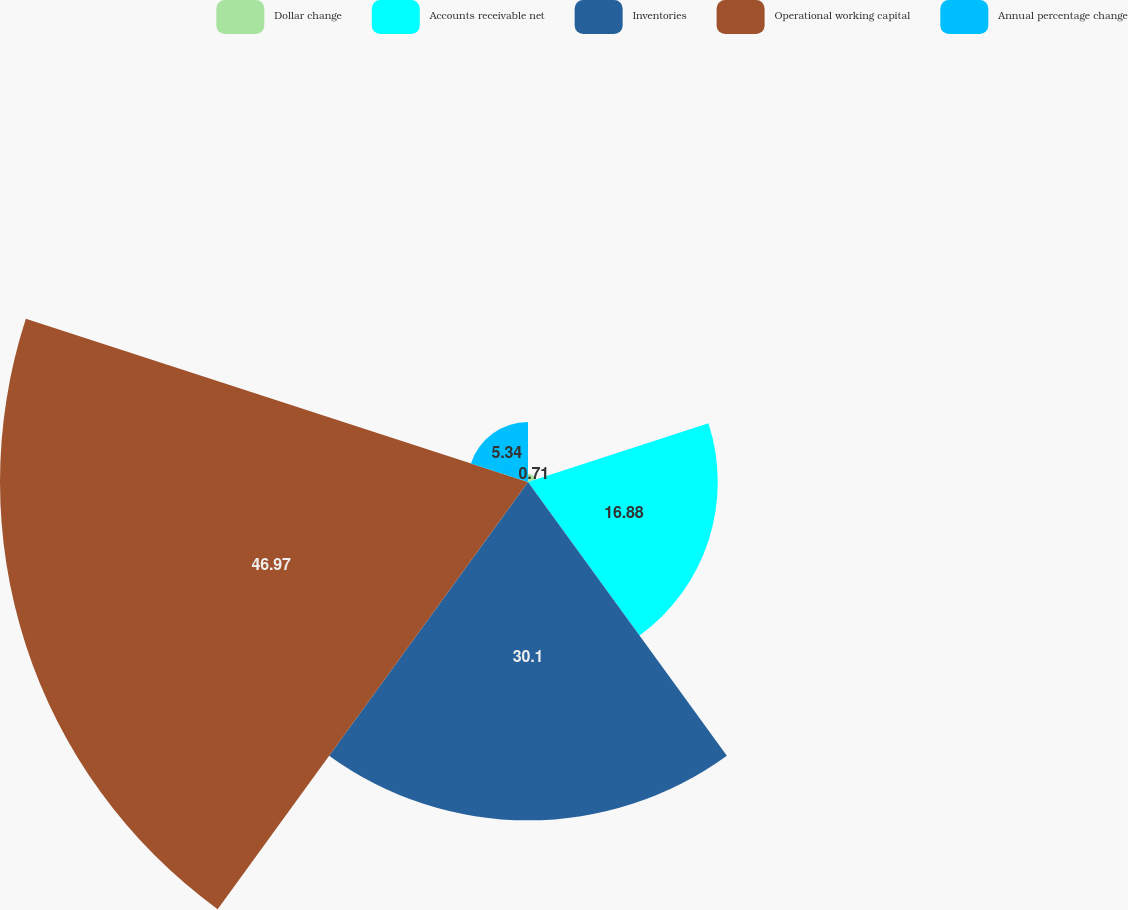Convert chart. <chart><loc_0><loc_0><loc_500><loc_500><pie_chart><fcel>Dollar change<fcel>Accounts receivable net<fcel>Inventories<fcel>Operational working capital<fcel>Annual percentage change<nl><fcel>0.71%<fcel>16.88%<fcel>30.1%<fcel>46.97%<fcel>5.34%<nl></chart> 